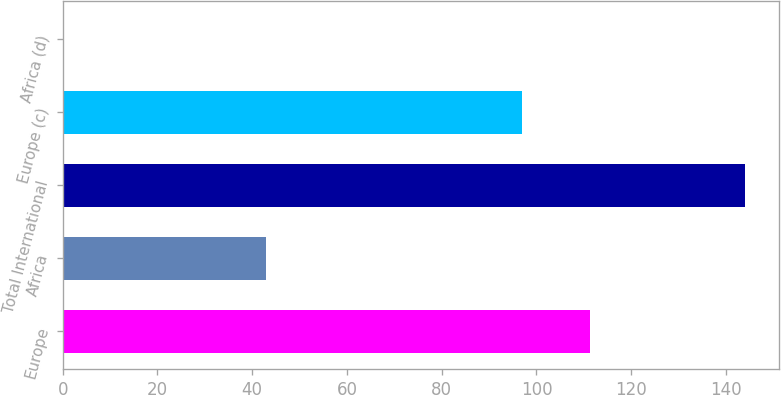<chart> <loc_0><loc_0><loc_500><loc_500><bar_chart><fcel>Europe<fcel>Africa<fcel>Total International<fcel>Europe (c)<fcel>Africa (d)<nl><fcel>111.38<fcel>43<fcel>144<fcel>97<fcel>0.24<nl></chart> 